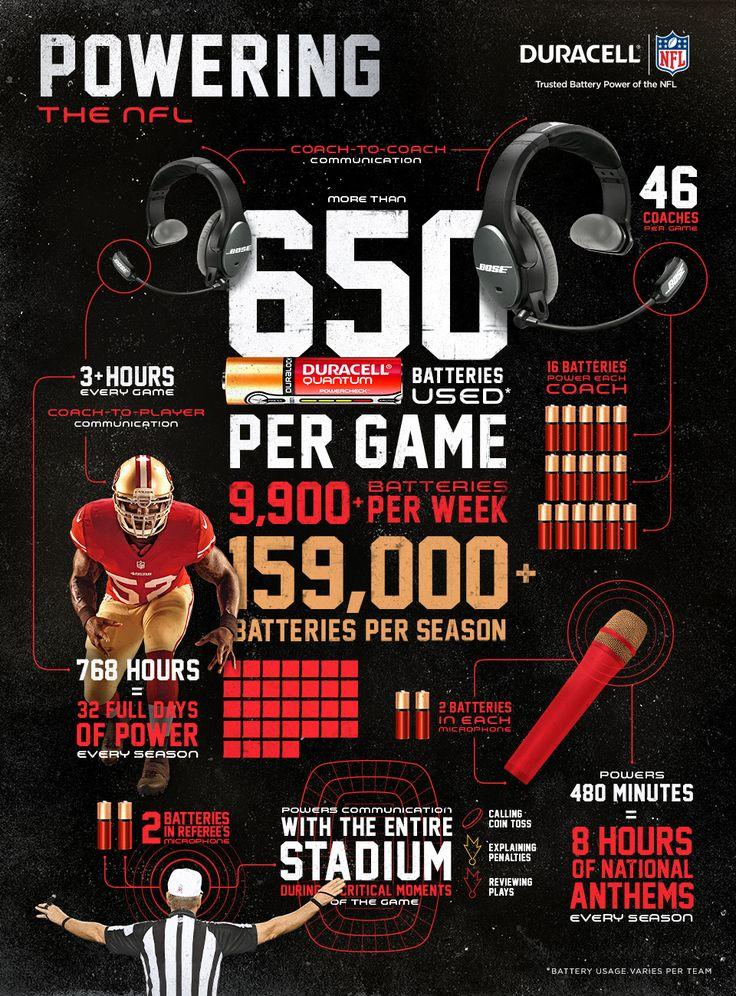Give some essential details in this illustration. It is possible to power a microphone for 480 minutes using two batteries. It is common for microphones to use two batteries. Each coach requires 16 batteries. During each game, coach-to-player communication takes place for approximately 3 hours. 